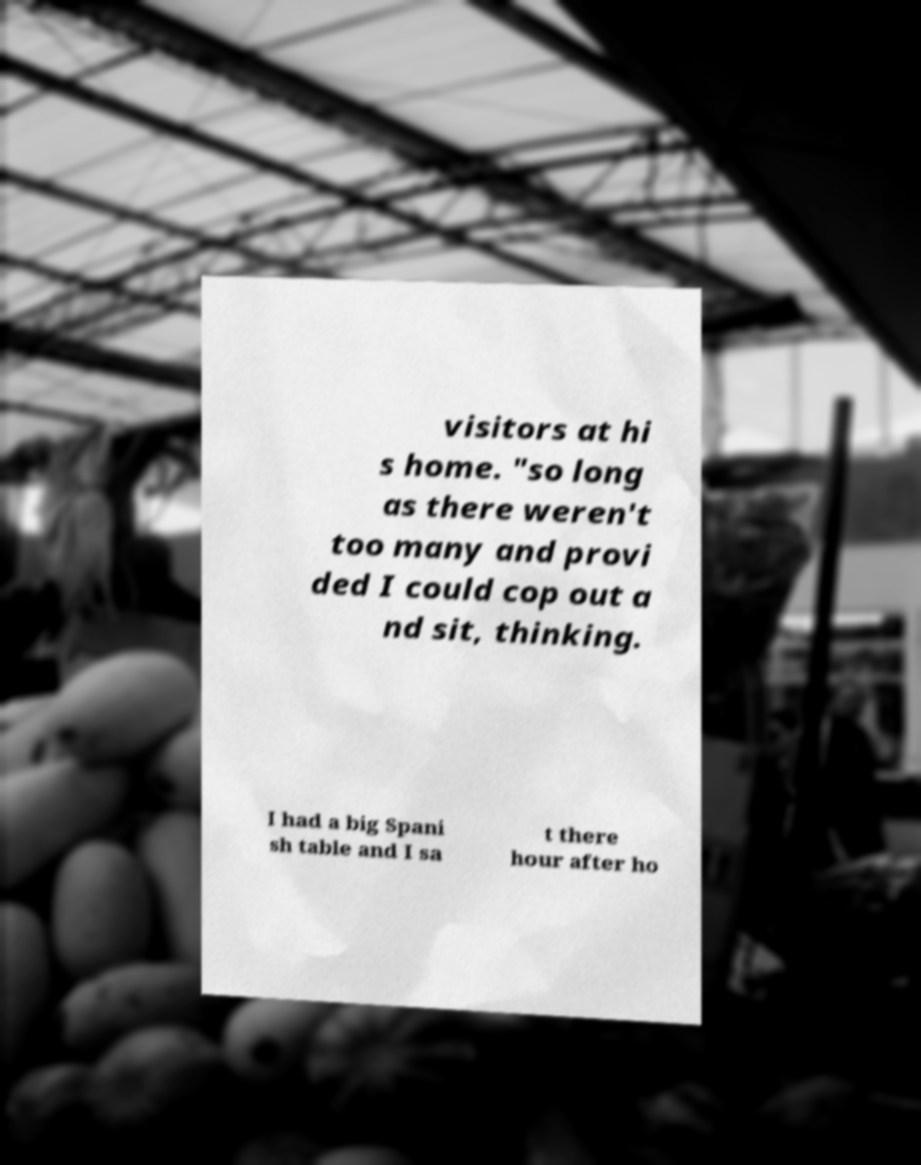Can you read and provide the text displayed in the image?This photo seems to have some interesting text. Can you extract and type it out for me? visitors at hi s home. "so long as there weren't too many and provi ded I could cop out a nd sit, thinking. I had a big Spani sh table and I sa t there hour after ho 